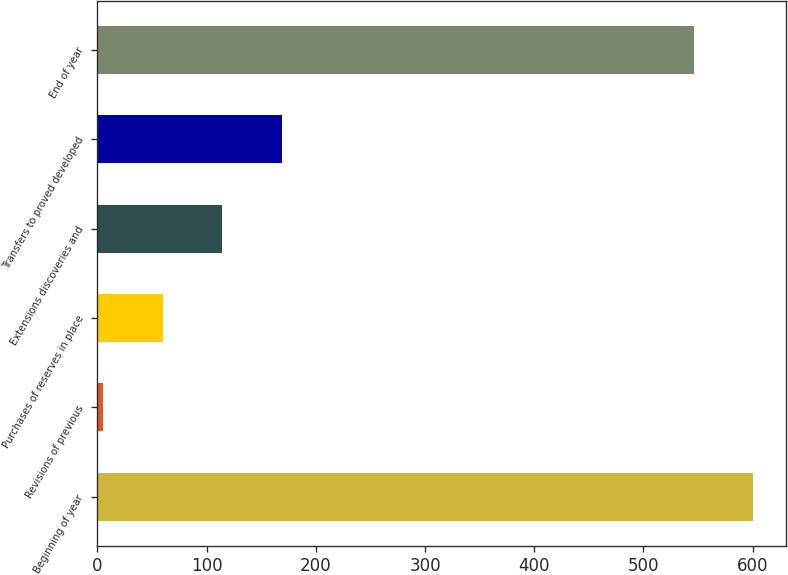<chart> <loc_0><loc_0><loc_500><loc_500><bar_chart><fcel>Beginning of year<fcel>Revisions of previous<fcel>Purchases of reserves in place<fcel>Extensions discoveries and<fcel>Transfers to proved developed<fcel>End of year<nl><fcel>600.7<fcel>5<fcel>59.7<fcel>114.4<fcel>169.1<fcel>546<nl></chart> 